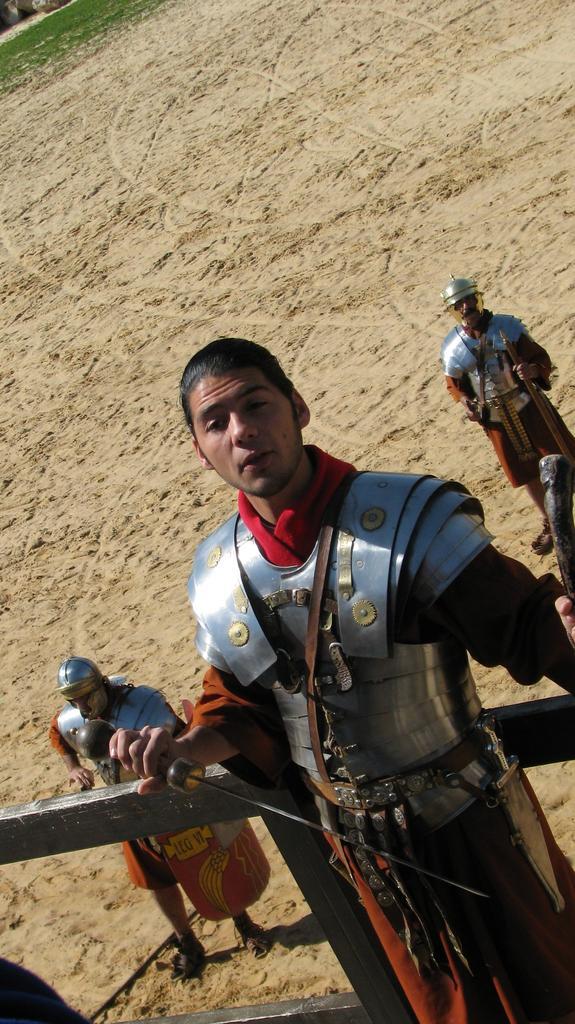Could you give a brief overview of what you see in this image? In this image, there are three people standing and holding the swords. This looks like a warrior suit. Here is the sand. 